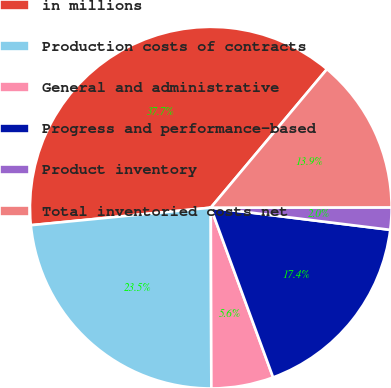Convert chart. <chart><loc_0><loc_0><loc_500><loc_500><pie_chart><fcel>in millions<fcel>Production costs of contracts<fcel>General and administrative<fcel>Progress and performance-based<fcel>Product inventory<fcel>Total inventoried costs net<nl><fcel>37.65%<fcel>23.5%<fcel>5.55%<fcel>17.44%<fcel>1.98%<fcel>13.87%<nl></chart> 